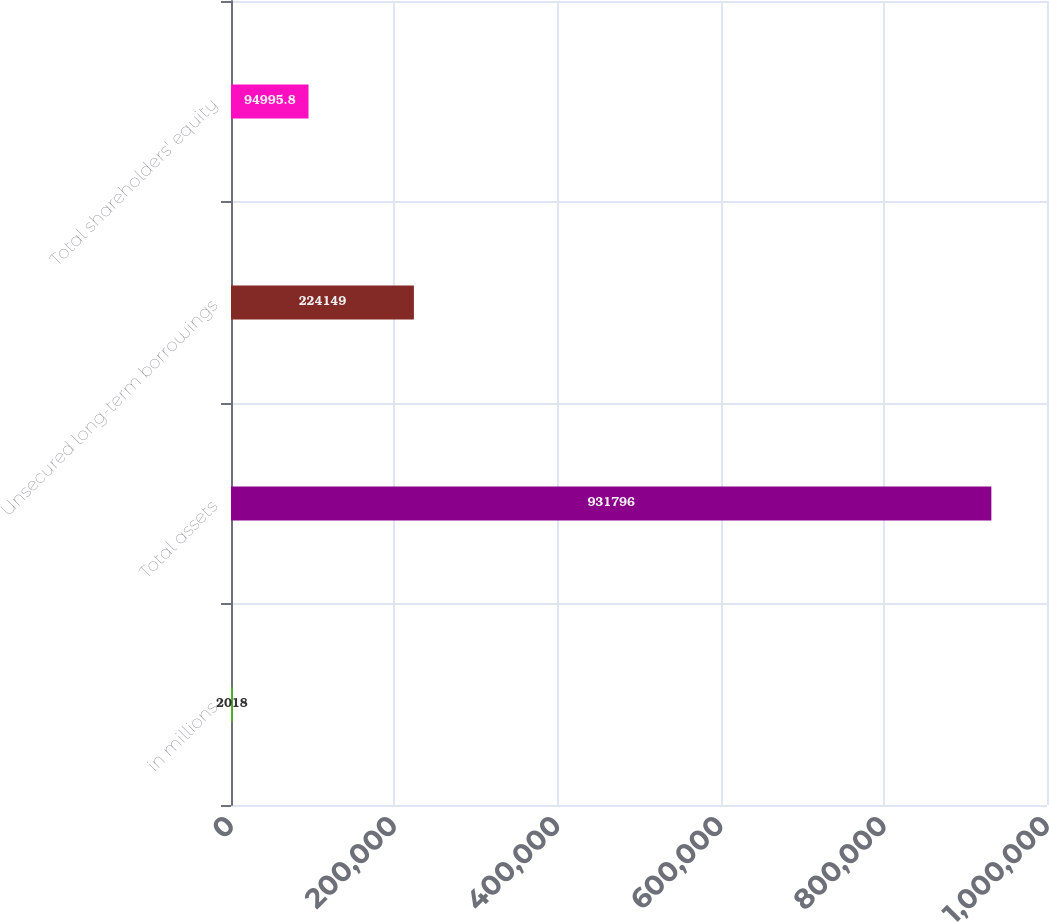<chart> <loc_0><loc_0><loc_500><loc_500><bar_chart><fcel>in millions<fcel>Total assets<fcel>Unsecured long-term borrowings<fcel>Total shareholders' equity<nl><fcel>2018<fcel>931796<fcel>224149<fcel>94995.8<nl></chart> 